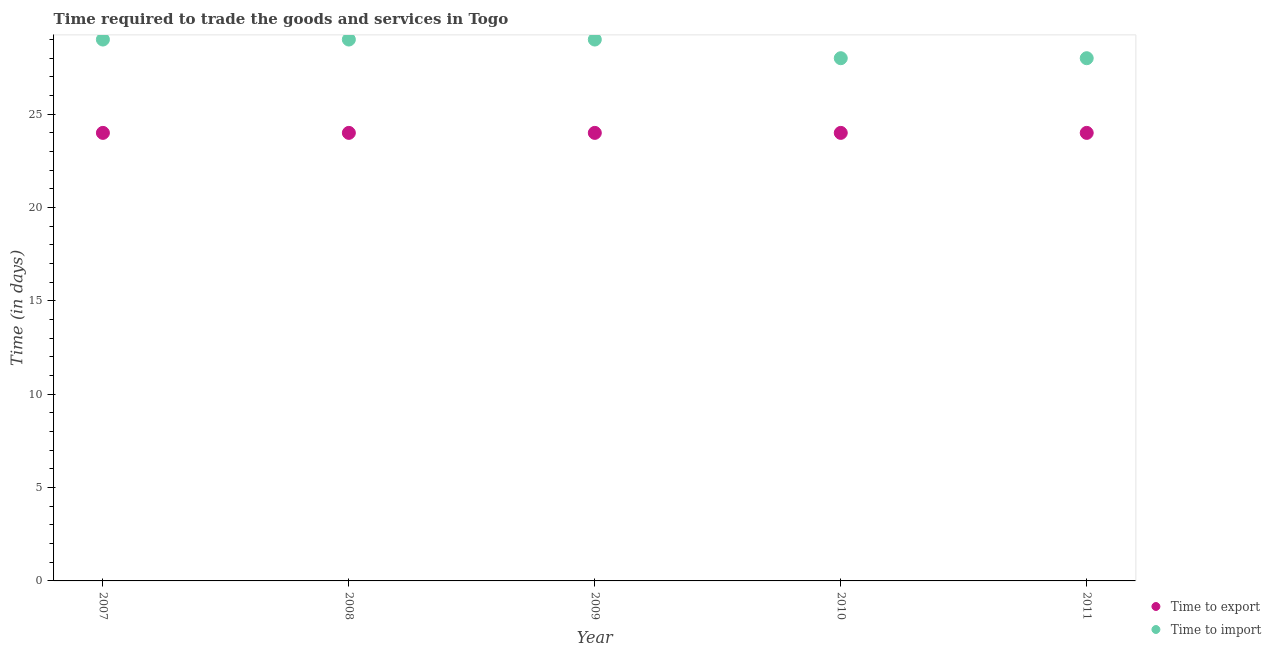Is the number of dotlines equal to the number of legend labels?
Your answer should be very brief. Yes. What is the time to export in 2008?
Give a very brief answer. 24. Across all years, what is the maximum time to export?
Your answer should be very brief. 24. Across all years, what is the minimum time to import?
Offer a terse response. 28. In which year was the time to export maximum?
Your answer should be very brief. 2007. What is the total time to import in the graph?
Ensure brevity in your answer.  143. What is the difference between the time to import in 2008 and that in 2010?
Offer a terse response. 1. What is the difference between the time to import in 2007 and the time to export in 2008?
Your response must be concise. 5. What is the average time to import per year?
Your answer should be very brief. 28.6. In the year 2009, what is the difference between the time to import and time to export?
Your response must be concise. 5. In how many years, is the time to import greater than 21 days?
Offer a terse response. 5. What is the ratio of the time to import in 2009 to that in 2010?
Provide a succinct answer. 1.04. Is the time to export in 2008 less than that in 2010?
Your response must be concise. No. What is the difference between the highest and the second highest time to import?
Your answer should be compact. 0. In how many years, is the time to export greater than the average time to export taken over all years?
Make the answer very short. 0. Does the time to export monotonically increase over the years?
Your answer should be compact. No. Is the time to export strictly greater than the time to import over the years?
Your answer should be very brief. No. Is the time to import strictly less than the time to export over the years?
Your answer should be very brief. No. Are the values on the major ticks of Y-axis written in scientific E-notation?
Your response must be concise. No. How are the legend labels stacked?
Provide a short and direct response. Vertical. What is the title of the graph?
Give a very brief answer. Time required to trade the goods and services in Togo. What is the label or title of the X-axis?
Your answer should be very brief. Year. What is the label or title of the Y-axis?
Your answer should be very brief. Time (in days). What is the Time (in days) of Time to import in 2008?
Your response must be concise. 29. What is the Time (in days) in Time to export in 2009?
Ensure brevity in your answer.  24. What is the Time (in days) of Time to import in 2009?
Provide a short and direct response. 29. What is the Time (in days) in Time to import in 2010?
Your answer should be very brief. 28. Across all years, what is the maximum Time (in days) in Time to export?
Your response must be concise. 24. Across all years, what is the minimum Time (in days) of Time to export?
Your answer should be very brief. 24. Across all years, what is the minimum Time (in days) in Time to import?
Keep it short and to the point. 28. What is the total Time (in days) of Time to export in the graph?
Ensure brevity in your answer.  120. What is the total Time (in days) in Time to import in the graph?
Your answer should be compact. 143. What is the difference between the Time (in days) of Time to export in 2007 and that in 2008?
Make the answer very short. 0. What is the difference between the Time (in days) in Time to export in 2007 and that in 2009?
Give a very brief answer. 0. What is the difference between the Time (in days) of Time to import in 2007 and that in 2009?
Ensure brevity in your answer.  0. What is the difference between the Time (in days) of Time to export in 2007 and that in 2010?
Provide a short and direct response. 0. What is the difference between the Time (in days) of Time to export in 2007 and that in 2011?
Your response must be concise. 0. What is the difference between the Time (in days) of Time to export in 2008 and that in 2009?
Offer a very short reply. 0. What is the difference between the Time (in days) of Time to import in 2008 and that in 2009?
Give a very brief answer. 0. What is the difference between the Time (in days) of Time to import in 2008 and that in 2010?
Offer a terse response. 1. What is the difference between the Time (in days) in Time to export in 2009 and that in 2010?
Keep it short and to the point. 0. What is the difference between the Time (in days) of Time to import in 2009 and that in 2011?
Provide a succinct answer. 1. What is the difference between the Time (in days) in Time to export in 2010 and that in 2011?
Your response must be concise. 0. What is the difference between the Time (in days) in Time to import in 2010 and that in 2011?
Your answer should be compact. 0. What is the difference between the Time (in days) of Time to export in 2007 and the Time (in days) of Time to import in 2008?
Offer a terse response. -5. What is the difference between the Time (in days) in Time to export in 2007 and the Time (in days) in Time to import in 2009?
Offer a terse response. -5. What is the difference between the Time (in days) in Time to export in 2008 and the Time (in days) in Time to import in 2010?
Provide a succinct answer. -4. What is the difference between the Time (in days) in Time to export in 2009 and the Time (in days) in Time to import in 2010?
Provide a succinct answer. -4. What is the difference between the Time (in days) in Time to export in 2010 and the Time (in days) in Time to import in 2011?
Ensure brevity in your answer.  -4. What is the average Time (in days) of Time to import per year?
Make the answer very short. 28.6. In the year 2007, what is the difference between the Time (in days) in Time to export and Time (in days) in Time to import?
Provide a short and direct response. -5. In the year 2009, what is the difference between the Time (in days) in Time to export and Time (in days) in Time to import?
Offer a terse response. -5. In the year 2010, what is the difference between the Time (in days) of Time to export and Time (in days) of Time to import?
Offer a terse response. -4. In the year 2011, what is the difference between the Time (in days) in Time to export and Time (in days) in Time to import?
Your answer should be compact. -4. What is the ratio of the Time (in days) in Time to import in 2007 to that in 2008?
Your answer should be compact. 1. What is the ratio of the Time (in days) of Time to export in 2007 to that in 2009?
Offer a very short reply. 1. What is the ratio of the Time (in days) of Time to import in 2007 to that in 2009?
Ensure brevity in your answer.  1. What is the ratio of the Time (in days) of Time to import in 2007 to that in 2010?
Your answer should be compact. 1.04. What is the ratio of the Time (in days) in Time to export in 2007 to that in 2011?
Give a very brief answer. 1. What is the ratio of the Time (in days) of Time to import in 2007 to that in 2011?
Keep it short and to the point. 1.04. What is the ratio of the Time (in days) of Time to export in 2008 to that in 2009?
Your response must be concise. 1. What is the ratio of the Time (in days) of Time to import in 2008 to that in 2009?
Provide a short and direct response. 1. What is the ratio of the Time (in days) in Time to export in 2008 to that in 2010?
Offer a very short reply. 1. What is the ratio of the Time (in days) in Time to import in 2008 to that in 2010?
Make the answer very short. 1.04. What is the ratio of the Time (in days) in Time to import in 2008 to that in 2011?
Your answer should be very brief. 1.04. What is the ratio of the Time (in days) of Time to export in 2009 to that in 2010?
Offer a very short reply. 1. What is the ratio of the Time (in days) in Time to import in 2009 to that in 2010?
Give a very brief answer. 1.04. What is the ratio of the Time (in days) of Time to import in 2009 to that in 2011?
Offer a terse response. 1.04. What is the ratio of the Time (in days) of Time to import in 2010 to that in 2011?
Make the answer very short. 1. What is the difference between the highest and the second highest Time (in days) of Time to export?
Offer a terse response. 0. What is the difference between the highest and the second highest Time (in days) in Time to import?
Give a very brief answer. 0. 